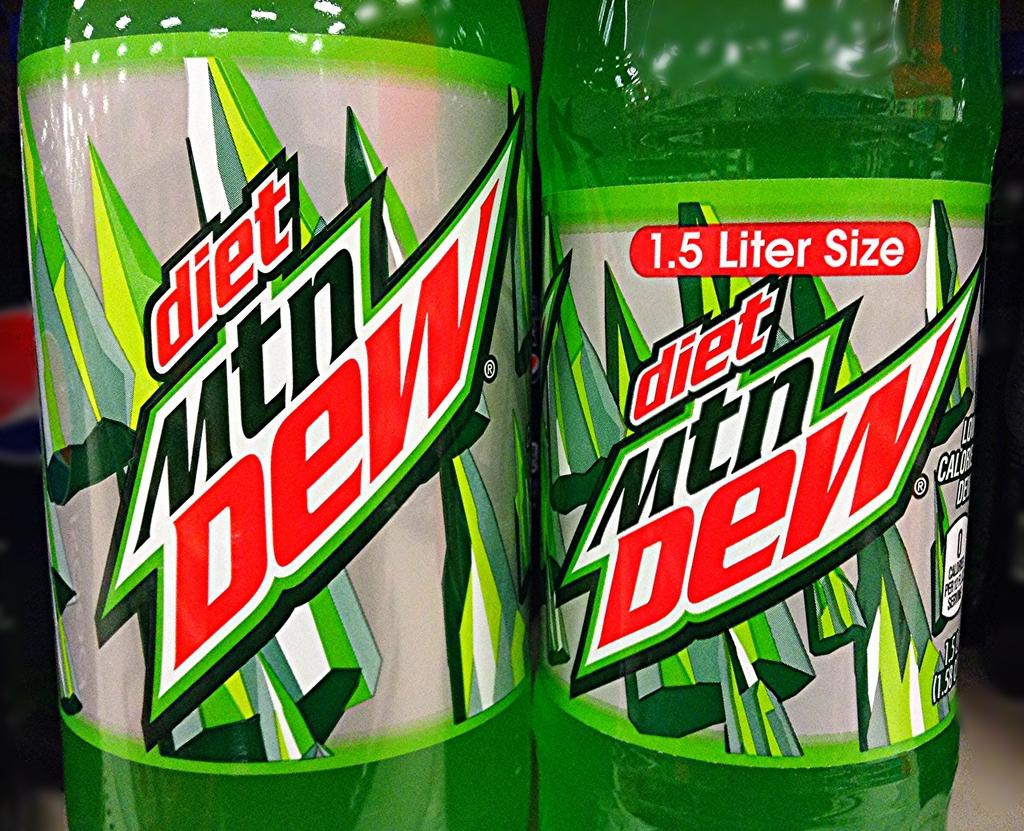<image>
Render a clear and concise summary of the photo. Two bottles of Diet Mtn Dew sit next to eachother 